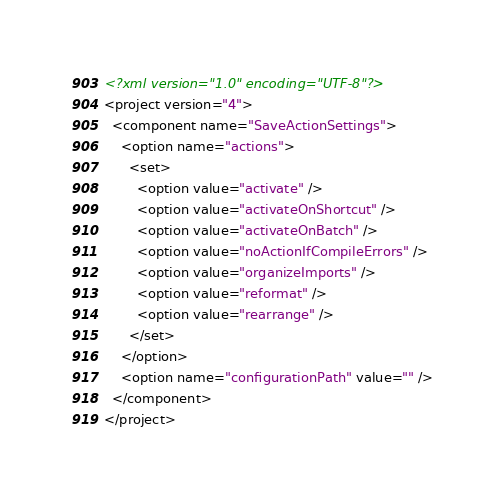<code> <loc_0><loc_0><loc_500><loc_500><_XML_><?xml version="1.0" encoding="UTF-8"?>
<project version="4">
  <component name="SaveActionSettings">
    <option name="actions">
      <set>
        <option value="activate" />
        <option value="activateOnShortcut" />
        <option value="activateOnBatch" />
        <option value="noActionIfCompileErrors" />
        <option value="organizeImports" />
        <option value="reformat" />
        <option value="rearrange" />
      </set>
    </option>
    <option name="configurationPath" value="" />
  </component>
</project></code> 